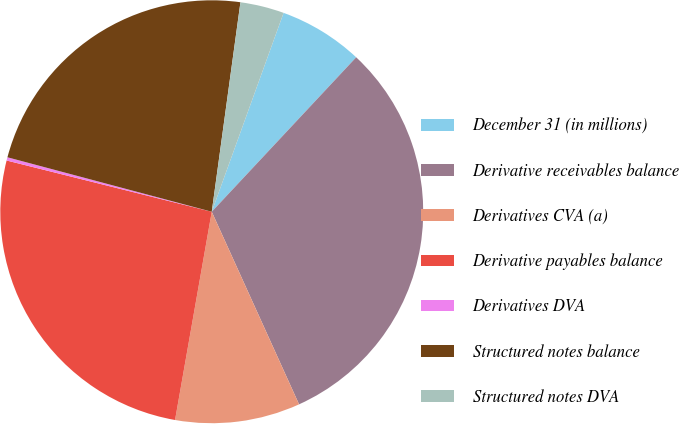Convert chart to OTSL. <chart><loc_0><loc_0><loc_500><loc_500><pie_chart><fcel>December 31 (in millions)<fcel>Derivative receivables balance<fcel>Derivatives CVA (a)<fcel>Derivative payables balance<fcel>Derivatives DVA<fcel>Structured notes balance<fcel>Structured notes DVA<nl><fcel>6.45%<fcel>31.26%<fcel>9.55%<fcel>26.12%<fcel>0.25%<fcel>23.02%<fcel>3.35%<nl></chart> 